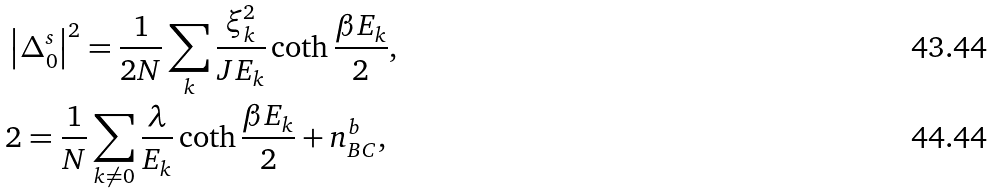<formula> <loc_0><loc_0><loc_500><loc_500>& \left | \Delta _ { 0 } ^ { s } \right | ^ { 2 } = \frac { 1 } { 2 N } \sum _ { k } \frac { \xi _ { k } ^ { 2 } } { J E _ { k } } \coth \frac { \beta E _ { k } } { 2 } , \\ & 2 = \frac { 1 } { N } \sum _ { k \neq 0 } \frac { \lambda } { E _ { k } } \coth \frac { \beta E _ { k } } { 2 } + n _ { B C } ^ { b } ,</formula> 